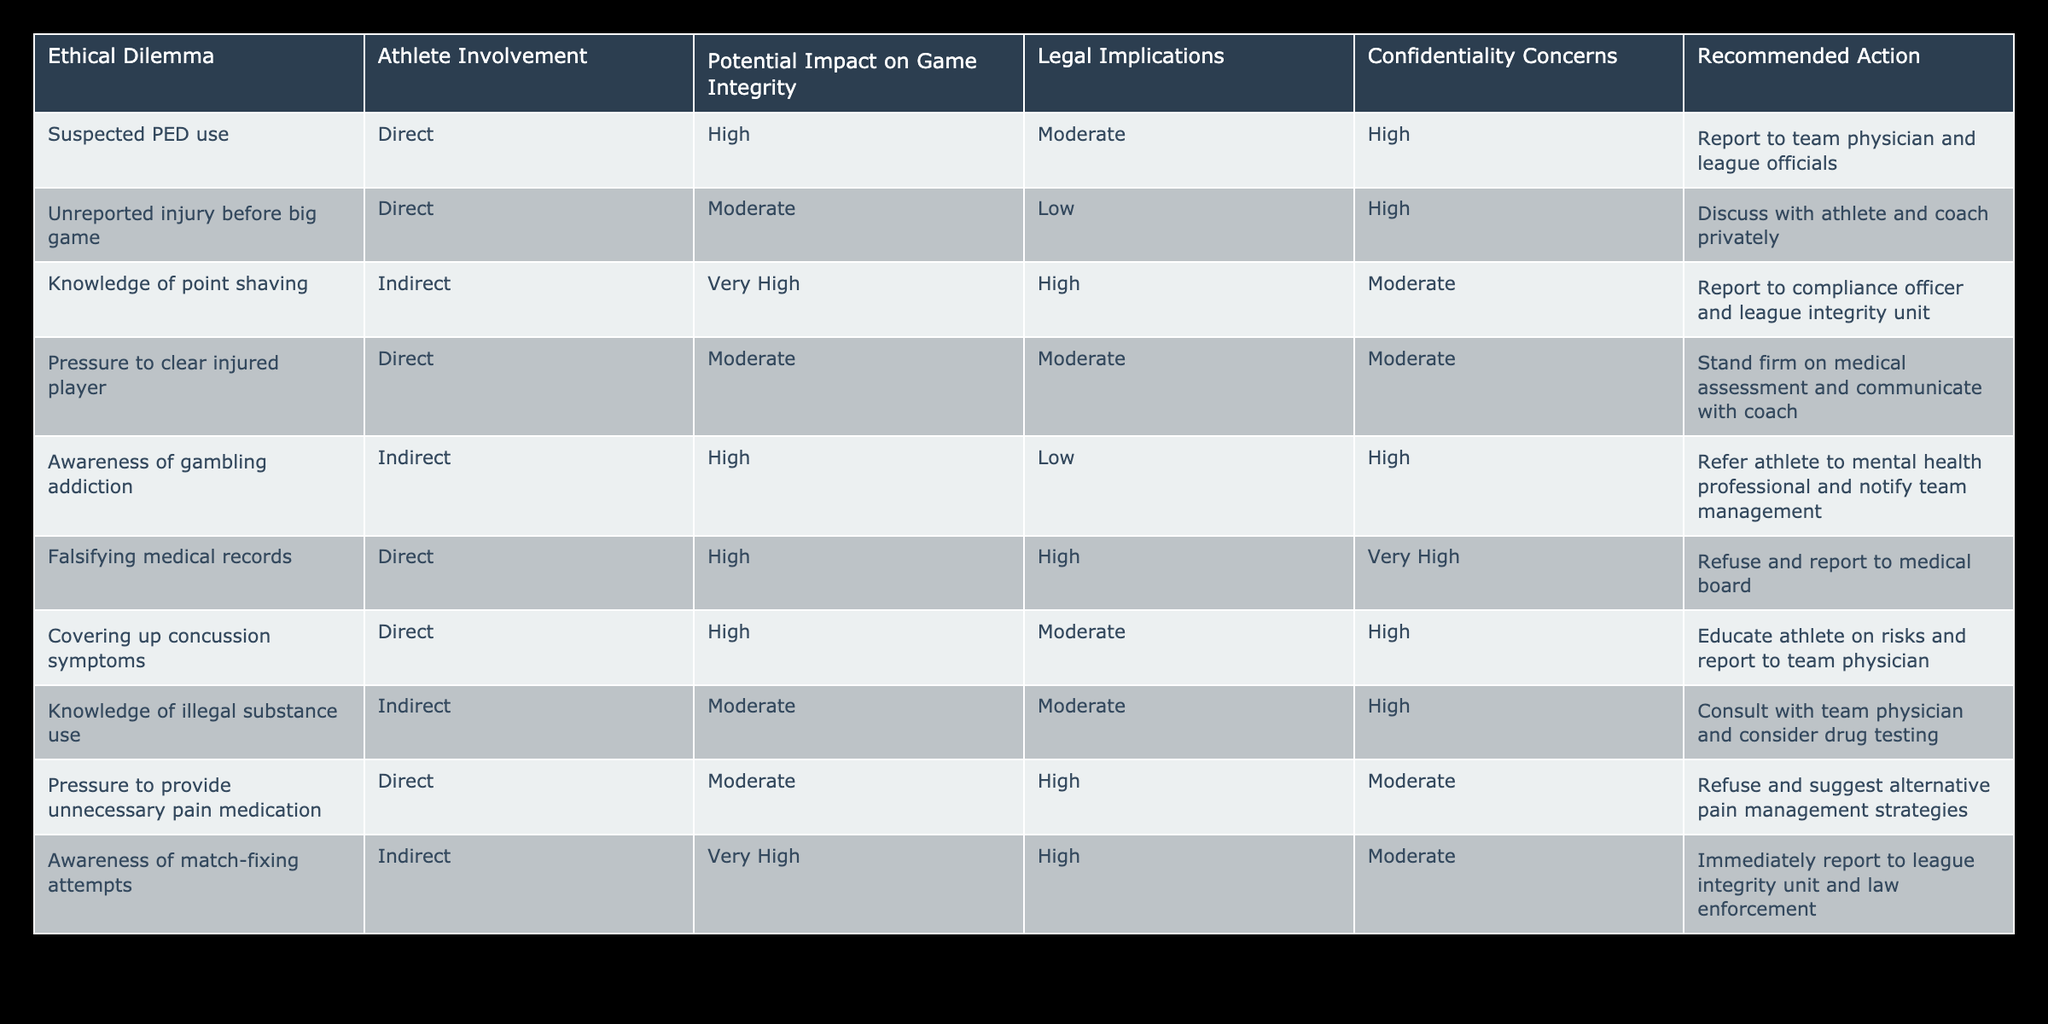What is the potential impact on game integrity for suspected PED use? The table indicates that suspected PED use has a potential impact on game integrity rated as High. This is found directly in the "Potential Impact on Game Integrity" column corresponding to the row with "Suspected PED use."
Answer: High What is the recommended action for covering up concussion symptoms? According to the table, the recommended action for covering up concussion symptoms is to educate the athlete on the risks and report to the team physician. This information is obtained from the relevant row in the table.
Answer: Educate athlete on risks and report to team physician How many ethical dilemmas involve indirect athlete involvement? The table lists two ethical dilemmas that involve indirect athlete involvement, those are "Awareness of gambling addiction" and "Knowledge of match-fixing attempts." We can count the rows where "Indirect" appears under the "Athlete Involvement" column.
Answer: 2 Is the legal implication of knowledge of point shaving high? The table indicates that the legal implication associated with knowledge of point shaving is High, as reflected in the "Legal Implications" column for that specific ethical dilemma.
Answer: Yes What is the difference in confidentiality concerns between awareness of gambling addiction and knowledge of illegal substance use? Awareness of gambling addiction has confidentiality concerns rated as High, while knowledge of illegal substance use has confidentiality concerns rated as High as well. Thus, there is no difference between them, as both are High. We can see this by comparing the "Confidentiality Concerns" column for both rows.
Answer: 0 What is the average potential impact on game integrity for all ethical dilemmas listed? Assigning numerical values to the potential impacts: Very High = 4, High = 3, Moderate = 2, Low = 1. There are five dilemmas rated as Very High, five as High, two as Moderate, and two as Low. Thus, the total impact score = (5*4) + (5*3) + (2*2) + (2*1) = 20 + 15 + 4 + 2 = 41. The average is then 41/(5+5+2+2) = 41/14 ≈ 2.93.
Answer: 2.93 What are the implications for confidentiality when an athlete is suspected of using illegal substances? The table states that the confidentiality concerns for knowledge of illegal substance use are rated High. This means there are significant concerns regarding the confidentiality of the information related to this ethical dilemma. This is derived from looking up the "Confidentiality Concerns" column for that row.
Answer: High What is the recommended action when there is pressure to clear an injured player? The recommended action in this scenario is to stand firm on the medical assessment and communicate with the coach. This can be found under the row for "Pressure to clear injured player" in the table.
Answer: Stand firm on medical assessment and communicate with coach 